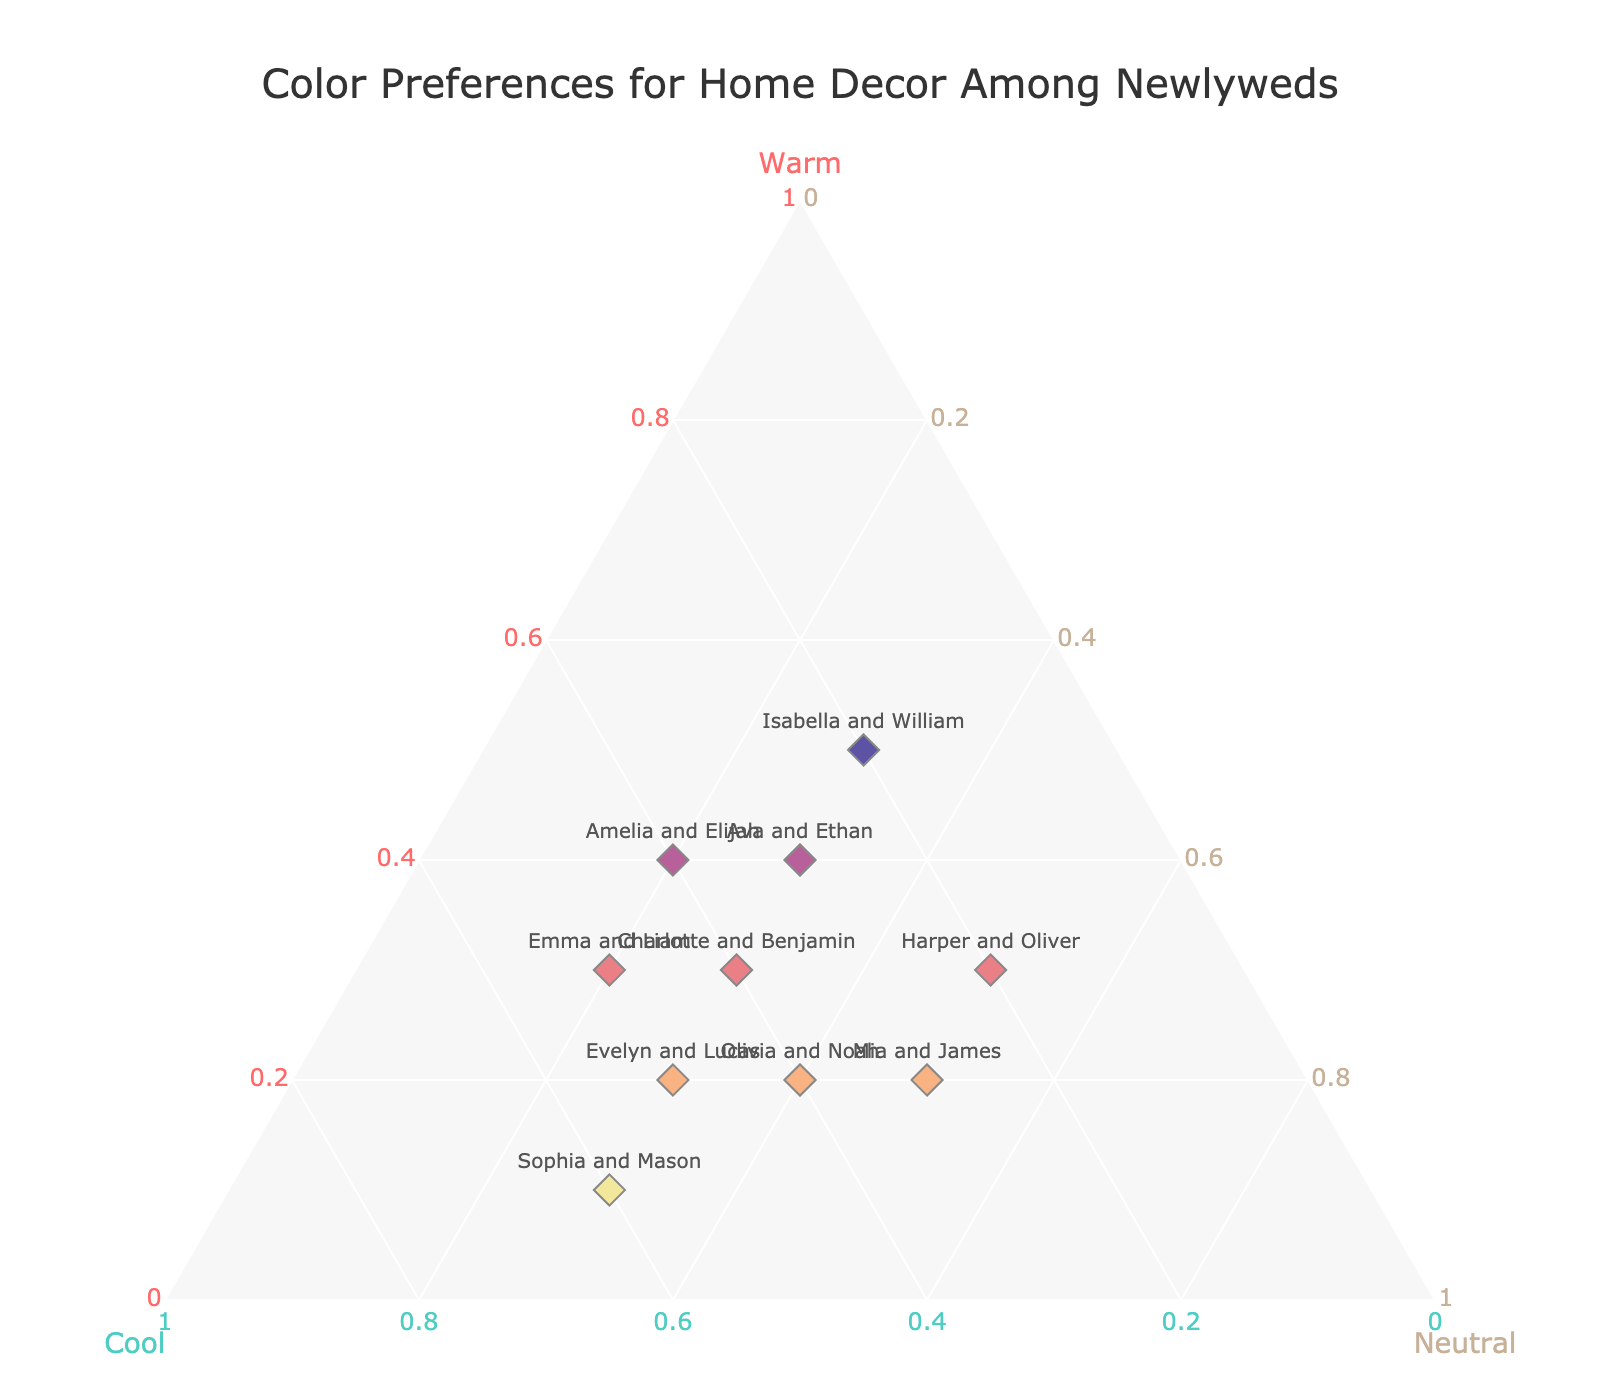What's the title of the chart? The title of the chart is written at the top center of the figure.
Answer: Color Preferences for Home Decor Among Newlyweds How many data points are there in the chart? You can count the number of data points (markers) in the ternary plot. Each couple represents one data point.
Answer: 10 Which couple prefers warm tones the most? Compare the values on the 'Warm' axis for all couples. Isabella and William have the highest value at 0.5.
Answer: Isabella and William Which couple has an equal preference for all three tones? Check the values for each couple where values for Warm, Cool, and Neutral are the same or closest. No couple has exactly balanced preferences, but Olivia and Noah have the most balanced values with Warm 0.2, Cool 0.4, Neutral 0.4.
Answer: Olivia and Noah Who prefers cool tones the least? Identify the points on the 'Cool' axis with the smallest values. Isabella and William have the lowest Cool value at 0.2.
Answer: Isabella and William What is the combined preference for neutral tones for all couples together? Sum up the neutral values for all couples: 0.2 + 0.4 + 0.3 + 0.3 + 0.3 + 0.5 + 0.3 + 0.2 + 0.5 + 0.3.
Answer: 3.3 Who has a preference ratio of Warm to Neutral closest to 1:1? Check the values where Warm and Neutral are approximately equal. Emma and Liam have the closest values with Warm 0.3 and Neutral 0.2.
Answer: Emma and Liam Which two couples have the closest total preferences for cool tones? Find the couples with similar Cool values: Emma and Liam and Evelyn and Lucas both have a Cool value of 0.5.
Answer: Emma and Liam and Evelyn and Lucas Is there any couple with a neutral preference higher than their warm and cool preferences combined? Check if the Neutral value is higher than the sum of Warm and Cool values for any couple. No couple has such a preference.
Answer: No Which couple has the most distinct difference in warm and cool tones? Calculate the absolute differences between the Warm and Cool values for each couple. Sophia and Mason show the biggest difference with Warm 0.1 and Cool 0.6, a difference of 0.5.
Answer: Sophia and Mason 